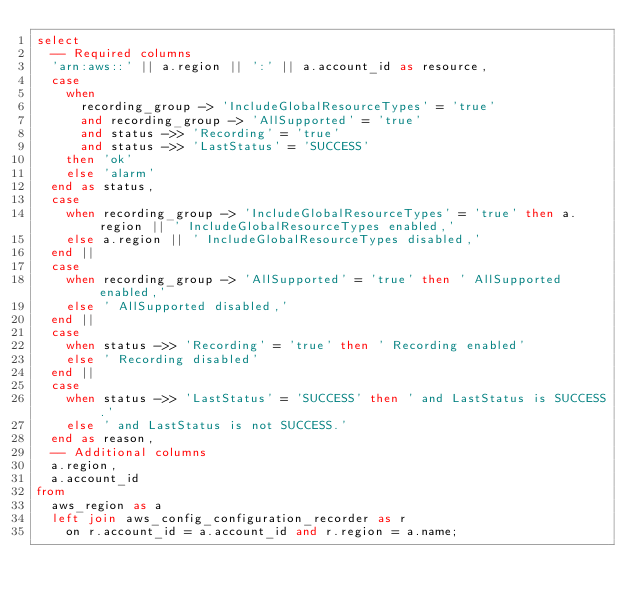Convert code to text. <code><loc_0><loc_0><loc_500><loc_500><_SQL_>select
  -- Required columns
  'arn:aws::' || a.region || ':' || a.account_id as resource,
  case
    when
      recording_group -> 'IncludeGlobalResourceTypes' = 'true'
      and recording_group -> 'AllSupported' = 'true'
      and status ->> 'Recording' = 'true'
      and status ->> 'LastStatus' = 'SUCCESS'
    then 'ok'
    else 'alarm'
  end as status,
  case
    when recording_group -> 'IncludeGlobalResourceTypes' = 'true' then a.region || ' IncludeGlobalResourceTypes enabled,'
    else a.region || ' IncludeGlobalResourceTypes disabled,'
  end ||
  case
    when recording_group -> 'AllSupported' = 'true' then ' AllSupported enabled,'
    else ' AllSupported disabled,'
  end ||
  case
    when status ->> 'Recording' = 'true' then ' Recording enabled'
    else ' Recording disabled'
  end ||
  case
    when status ->> 'LastStatus' = 'SUCCESS' then ' and LastStatus is SUCCESS.'
    else ' and LastStatus is not SUCCESS.'
  end as reason,
  -- Additional columns
  a.region,
  a.account_id
from
  aws_region as a
  left join aws_config_configuration_recorder as r 
    on r.account_id = a.account_id and r.region = a.name;
</code> 